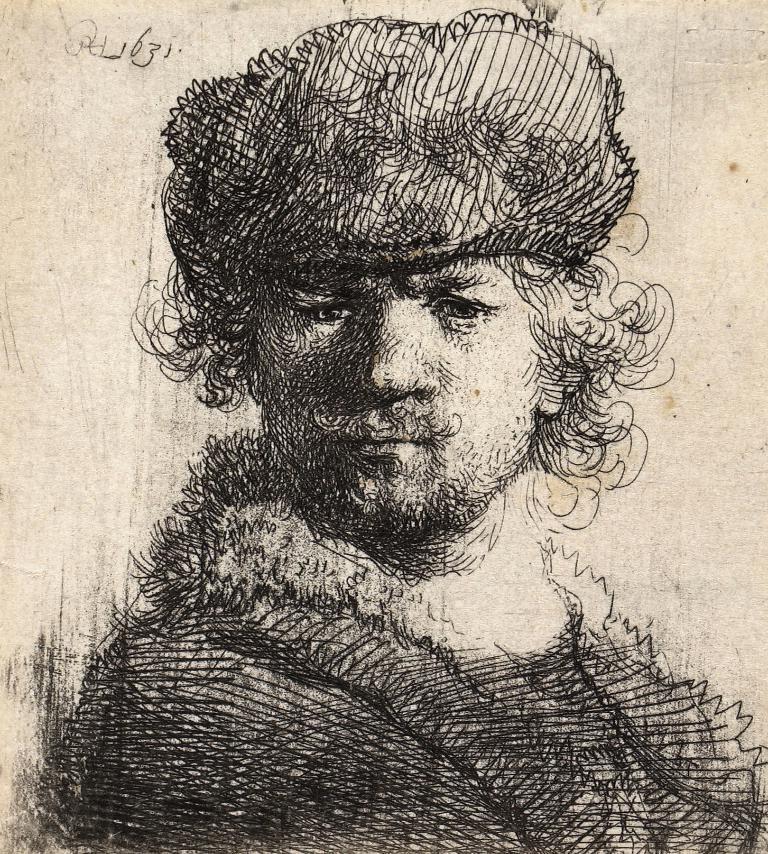Could you give a brief overview of what you see in this image? In this picture we can see art of a man. 